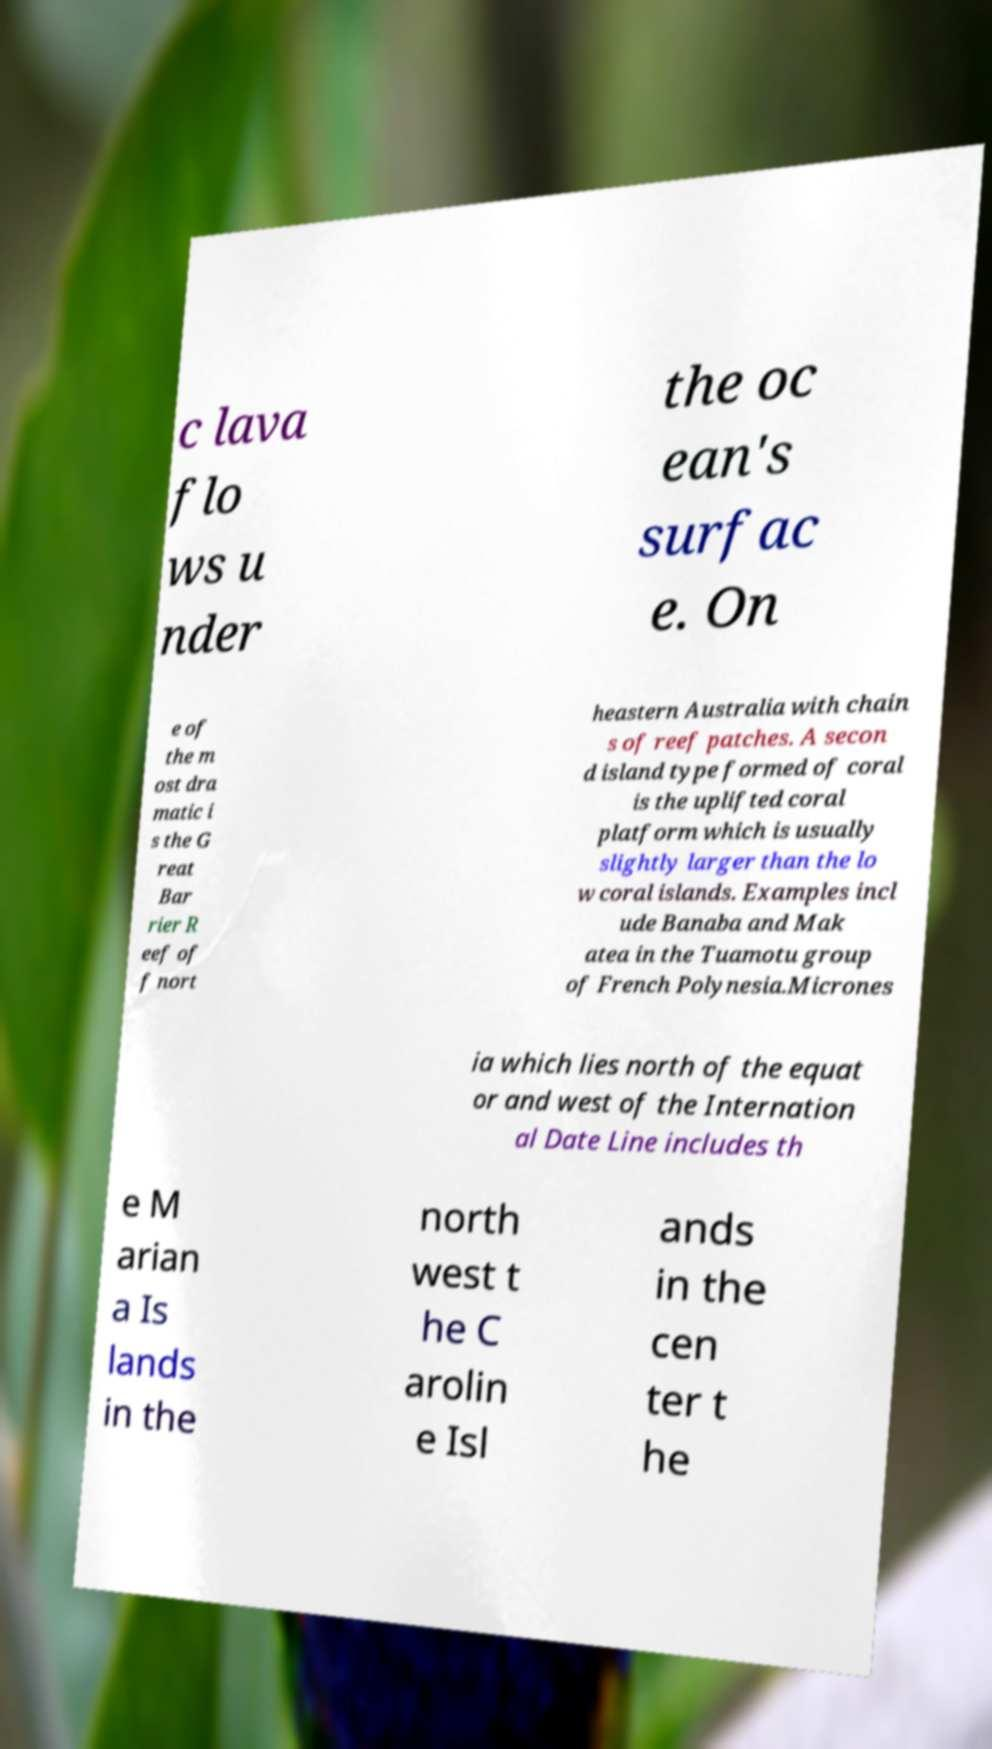Can you read and provide the text displayed in the image?This photo seems to have some interesting text. Can you extract and type it out for me? c lava flo ws u nder the oc ean's surfac e. On e of the m ost dra matic i s the G reat Bar rier R eef of f nort heastern Australia with chain s of reef patches. A secon d island type formed of coral is the uplifted coral platform which is usually slightly larger than the lo w coral islands. Examples incl ude Banaba and Mak atea in the Tuamotu group of French Polynesia.Micrones ia which lies north of the equat or and west of the Internation al Date Line includes th e M arian a Is lands in the north west t he C arolin e Isl ands in the cen ter t he 